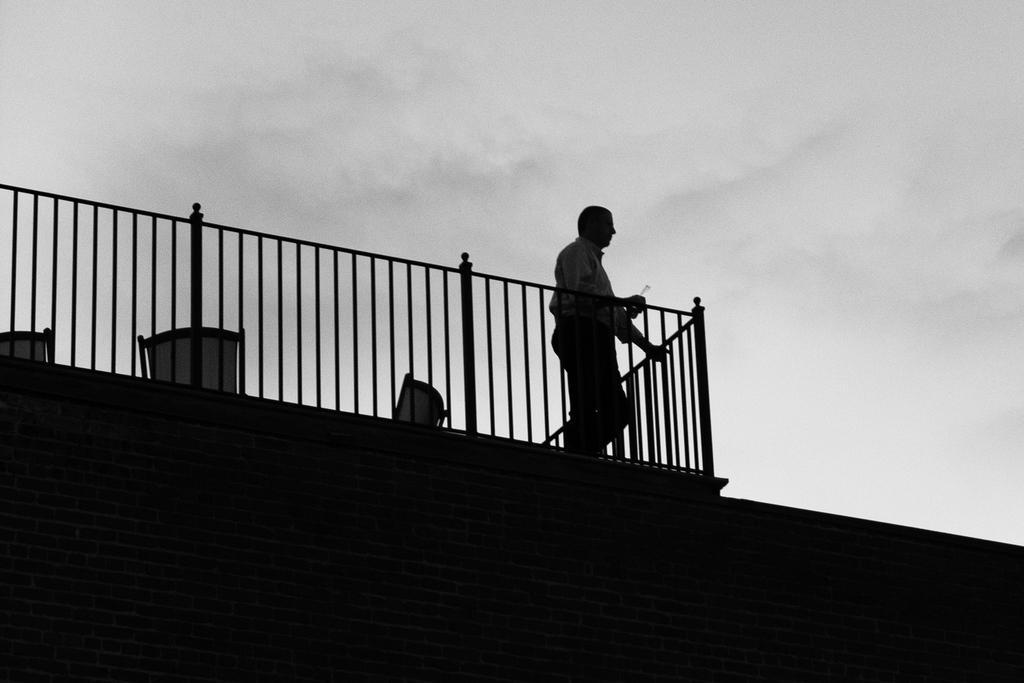How would you summarize this image in a sentence or two? In this picture we can see a person standing on a building and we can see sky in the background. 